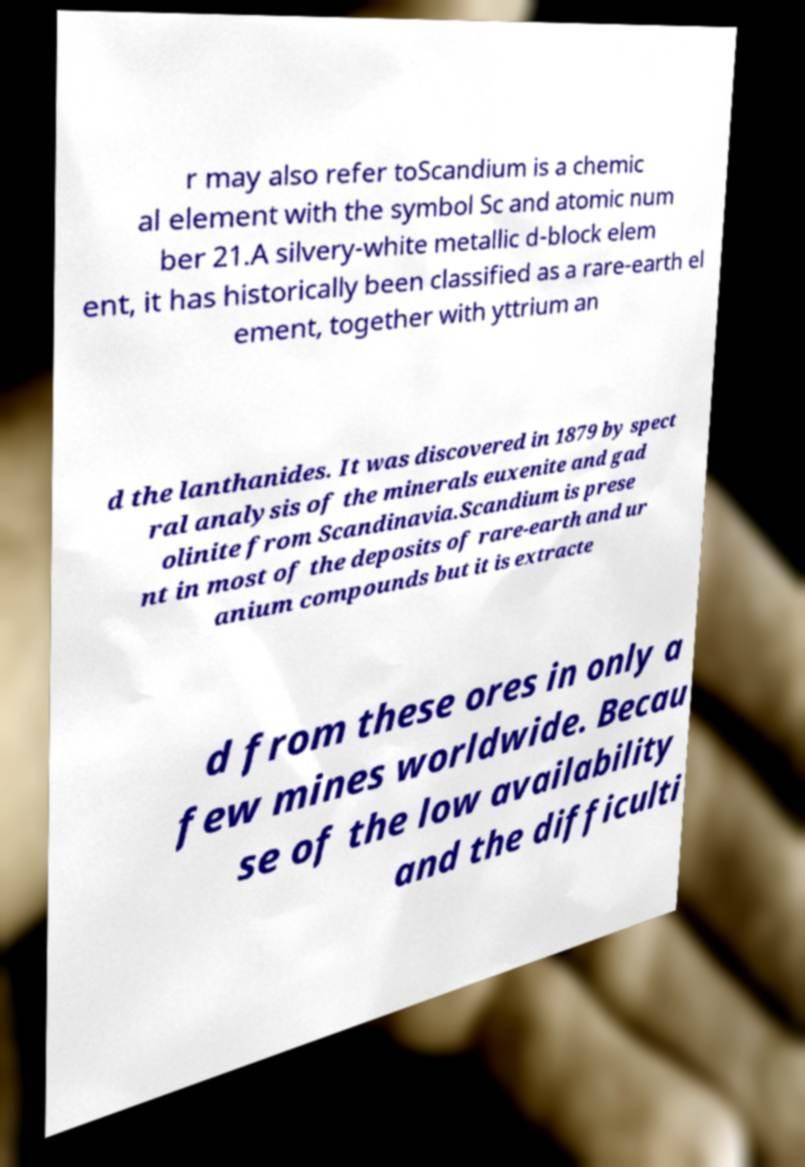Please identify and transcribe the text found in this image. r may also refer toScandium is a chemic al element with the symbol Sc and atomic num ber 21.A silvery-white metallic d-block elem ent, it has historically been classified as a rare-earth el ement, together with yttrium an d the lanthanides. It was discovered in 1879 by spect ral analysis of the minerals euxenite and gad olinite from Scandinavia.Scandium is prese nt in most of the deposits of rare-earth and ur anium compounds but it is extracte d from these ores in only a few mines worldwide. Becau se of the low availability and the difficulti 